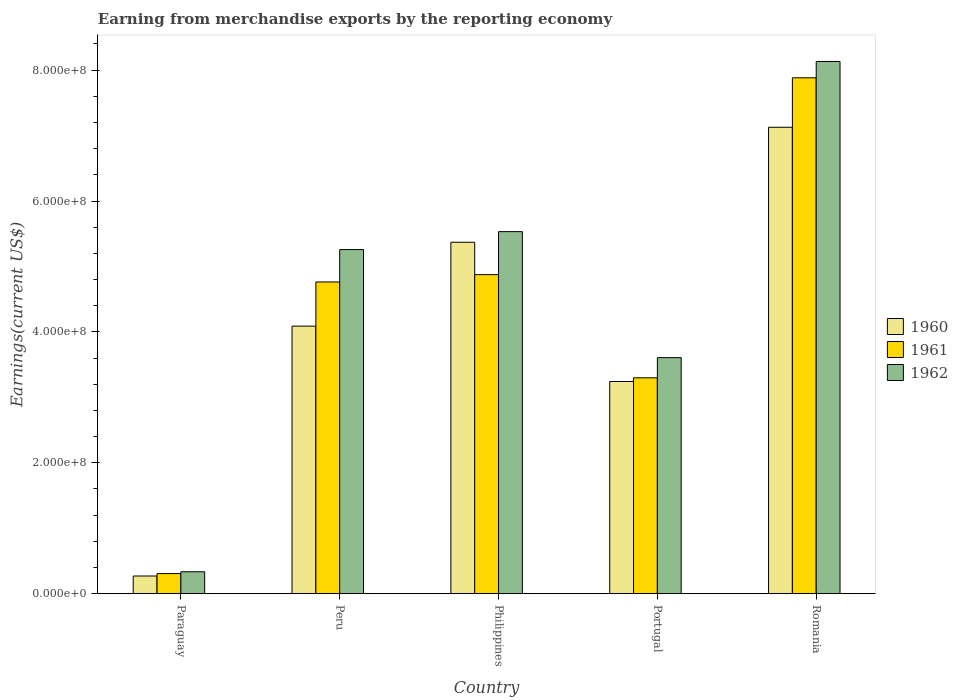How many groups of bars are there?
Ensure brevity in your answer.  5. Are the number of bars on each tick of the X-axis equal?
Provide a succinct answer. Yes. What is the label of the 1st group of bars from the left?
Give a very brief answer. Paraguay. In how many cases, is the number of bars for a given country not equal to the number of legend labels?
Make the answer very short. 0. What is the amount earned from merchandise exports in 1960 in Philippines?
Your response must be concise. 5.37e+08. Across all countries, what is the maximum amount earned from merchandise exports in 1962?
Your answer should be very brief. 8.13e+08. Across all countries, what is the minimum amount earned from merchandise exports in 1961?
Make the answer very short. 3.07e+07. In which country was the amount earned from merchandise exports in 1961 maximum?
Ensure brevity in your answer.  Romania. In which country was the amount earned from merchandise exports in 1961 minimum?
Provide a short and direct response. Paraguay. What is the total amount earned from merchandise exports in 1960 in the graph?
Provide a short and direct response. 2.01e+09. What is the difference between the amount earned from merchandise exports in 1961 in Philippines and that in Romania?
Your answer should be compact. -3.01e+08. What is the difference between the amount earned from merchandise exports in 1961 in Portugal and the amount earned from merchandise exports in 1962 in Peru?
Your answer should be compact. -1.96e+08. What is the average amount earned from merchandise exports in 1961 per country?
Your answer should be very brief. 4.23e+08. What is the difference between the amount earned from merchandise exports of/in 1961 and amount earned from merchandise exports of/in 1962 in Philippines?
Offer a very short reply. -6.57e+07. What is the ratio of the amount earned from merchandise exports in 1961 in Paraguay to that in Romania?
Ensure brevity in your answer.  0.04. Is the amount earned from merchandise exports in 1961 in Paraguay less than that in Philippines?
Provide a short and direct response. Yes. Is the difference between the amount earned from merchandise exports in 1961 in Paraguay and Portugal greater than the difference between the amount earned from merchandise exports in 1962 in Paraguay and Portugal?
Offer a terse response. Yes. What is the difference between the highest and the second highest amount earned from merchandise exports in 1962?
Your response must be concise. 2.87e+08. What is the difference between the highest and the lowest amount earned from merchandise exports in 1962?
Keep it short and to the point. 7.80e+08. Is the sum of the amount earned from merchandise exports in 1962 in Paraguay and Peru greater than the maximum amount earned from merchandise exports in 1960 across all countries?
Provide a short and direct response. No. What does the 2nd bar from the left in Paraguay represents?
Provide a short and direct response. 1961. What does the 2nd bar from the right in Paraguay represents?
Ensure brevity in your answer.  1961. How many bars are there?
Offer a terse response. 15. Are the values on the major ticks of Y-axis written in scientific E-notation?
Offer a terse response. Yes. Where does the legend appear in the graph?
Your answer should be compact. Center right. What is the title of the graph?
Your answer should be compact. Earning from merchandise exports by the reporting economy. What is the label or title of the X-axis?
Offer a terse response. Country. What is the label or title of the Y-axis?
Provide a succinct answer. Earnings(current US$). What is the Earnings(current US$) of 1960 in Paraguay?
Provide a short and direct response. 2.70e+07. What is the Earnings(current US$) in 1961 in Paraguay?
Your answer should be compact. 3.07e+07. What is the Earnings(current US$) of 1962 in Paraguay?
Offer a terse response. 3.35e+07. What is the Earnings(current US$) of 1960 in Peru?
Your answer should be compact. 4.09e+08. What is the Earnings(current US$) in 1961 in Peru?
Give a very brief answer. 4.76e+08. What is the Earnings(current US$) in 1962 in Peru?
Provide a short and direct response. 5.26e+08. What is the Earnings(current US$) in 1960 in Philippines?
Offer a very short reply. 5.37e+08. What is the Earnings(current US$) of 1961 in Philippines?
Provide a short and direct response. 4.88e+08. What is the Earnings(current US$) in 1962 in Philippines?
Your response must be concise. 5.53e+08. What is the Earnings(current US$) in 1960 in Portugal?
Offer a very short reply. 3.24e+08. What is the Earnings(current US$) in 1961 in Portugal?
Your answer should be very brief. 3.30e+08. What is the Earnings(current US$) in 1962 in Portugal?
Offer a terse response. 3.61e+08. What is the Earnings(current US$) of 1960 in Romania?
Offer a very short reply. 7.13e+08. What is the Earnings(current US$) of 1961 in Romania?
Your answer should be compact. 7.88e+08. What is the Earnings(current US$) in 1962 in Romania?
Offer a terse response. 8.13e+08. Across all countries, what is the maximum Earnings(current US$) of 1960?
Provide a succinct answer. 7.13e+08. Across all countries, what is the maximum Earnings(current US$) in 1961?
Make the answer very short. 7.88e+08. Across all countries, what is the maximum Earnings(current US$) of 1962?
Your answer should be compact. 8.13e+08. Across all countries, what is the minimum Earnings(current US$) in 1960?
Your response must be concise. 2.70e+07. Across all countries, what is the minimum Earnings(current US$) of 1961?
Your answer should be very brief. 3.07e+07. Across all countries, what is the minimum Earnings(current US$) of 1962?
Offer a terse response. 3.35e+07. What is the total Earnings(current US$) of 1960 in the graph?
Provide a succinct answer. 2.01e+09. What is the total Earnings(current US$) in 1961 in the graph?
Your response must be concise. 2.11e+09. What is the total Earnings(current US$) in 1962 in the graph?
Your answer should be very brief. 2.29e+09. What is the difference between the Earnings(current US$) in 1960 in Paraguay and that in Peru?
Provide a short and direct response. -3.82e+08. What is the difference between the Earnings(current US$) of 1961 in Paraguay and that in Peru?
Provide a short and direct response. -4.46e+08. What is the difference between the Earnings(current US$) in 1962 in Paraguay and that in Peru?
Provide a short and direct response. -4.92e+08. What is the difference between the Earnings(current US$) of 1960 in Paraguay and that in Philippines?
Ensure brevity in your answer.  -5.10e+08. What is the difference between the Earnings(current US$) in 1961 in Paraguay and that in Philippines?
Your answer should be very brief. -4.57e+08. What is the difference between the Earnings(current US$) of 1962 in Paraguay and that in Philippines?
Offer a terse response. -5.20e+08. What is the difference between the Earnings(current US$) of 1960 in Paraguay and that in Portugal?
Provide a succinct answer. -2.97e+08. What is the difference between the Earnings(current US$) in 1961 in Paraguay and that in Portugal?
Offer a very short reply. -2.99e+08. What is the difference between the Earnings(current US$) in 1962 in Paraguay and that in Portugal?
Your answer should be very brief. -3.27e+08. What is the difference between the Earnings(current US$) of 1960 in Paraguay and that in Romania?
Provide a short and direct response. -6.86e+08. What is the difference between the Earnings(current US$) of 1961 in Paraguay and that in Romania?
Your answer should be compact. -7.58e+08. What is the difference between the Earnings(current US$) of 1962 in Paraguay and that in Romania?
Ensure brevity in your answer.  -7.80e+08. What is the difference between the Earnings(current US$) in 1960 in Peru and that in Philippines?
Offer a terse response. -1.28e+08. What is the difference between the Earnings(current US$) in 1961 in Peru and that in Philippines?
Provide a succinct answer. -1.12e+07. What is the difference between the Earnings(current US$) of 1962 in Peru and that in Philippines?
Offer a very short reply. -2.74e+07. What is the difference between the Earnings(current US$) of 1960 in Peru and that in Portugal?
Your answer should be very brief. 8.46e+07. What is the difference between the Earnings(current US$) of 1961 in Peru and that in Portugal?
Offer a very short reply. 1.46e+08. What is the difference between the Earnings(current US$) in 1962 in Peru and that in Portugal?
Provide a succinct answer. 1.65e+08. What is the difference between the Earnings(current US$) of 1960 in Peru and that in Romania?
Your answer should be compact. -3.04e+08. What is the difference between the Earnings(current US$) in 1961 in Peru and that in Romania?
Your answer should be very brief. -3.12e+08. What is the difference between the Earnings(current US$) of 1962 in Peru and that in Romania?
Your response must be concise. -2.87e+08. What is the difference between the Earnings(current US$) of 1960 in Philippines and that in Portugal?
Provide a succinct answer. 2.13e+08. What is the difference between the Earnings(current US$) in 1961 in Philippines and that in Portugal?
Provide a short and direct response. 1.58e+08. What is the difference between the Earnings(current US$) of 1962 in Philippines and that in Portugal?
Ensure brevity in your answer.  1.93e+08. What is the difference between the Earnings(current US$) of 1960 in Philippines and that in Romania?
Provide a succinct answer. -1.76e+08. What is the difference between the Earnings(current US$) of 1961 in Philippines and that in Romania?
Keep it short and to the point. -3.01e+08. What is the difference between the Earnings(current US$) of 1962 in Philippines and that in Romania?
Your response must be concise. -2.60e+08. What is the difference between the Earnings(current US$) in 1960 in Portugal and that in Romania?
Give a very brief answer. -3.89e+08. What is the difference between the Earnings(current US$) of 1961 in Portugal and that in Romania?
Keep it short and to the point. -4.58e+08. What is the difference between the Earnings(current US$) in 1962 in Portugal and that in Romania?
Provide a short and direct response. -4.53e+08. What is the difference between the Earnings(current US$) in 1960 in Paraguay and the Earnings(current US$) in 1961 in Peru?
Give a very brief answer. -4.49e+08. What is the difference between the Earnings(current US$) in 1960 in Paraguay and the Earnings(current US$) in 1962 in Peru?
Make the answer very short. -4.99e+08. What is the difference between the Earnings(current US$) of 1961 in Paraguay and the Earnings(current US$) of 1962 in Peru?
Provide a short and direct response. -4.95e+08. What is the difference between the Earnings(current US$) in 1960 in Paraguay and the Earnings(current US$) in 1961 in Philippines?
Ensure brevity in your answer.  -4.61e+08. What is the difference between the Earnings(current US$) in 1960 in Paraguay and the Earnings(current US$) in 1962 in Philippines?
Make the answer very short. -5.26e+08. What is the difference between the Earnings(current US$) in 1961 in Paraguay and the Earnings(current US$) in 1962 in Philippines?
Offer a very short reply. -5.23e+08. What is the difference between the Earnings(current US$) of 1960 in Paraguay and the Earnings(current US$) of 1961 in Portugal?
Your response must be concise. -3.03e+08. What is the difference between the Earnings(current US$) of 1960 in Paraguay and the Earnings(current US$) of 1962 in Portugal?
Keep it short and to the point. -3.34e+08. What is the difference between the Earnings(current US$) in 1961 in Paraguay and the Earnings(current US$) in 1962 in Portugal?
Your response must be concise. -3.30e+08. What is the difference between the Earnings(current US$) in 1960 in Paraguay and the Earnings(current US$) in 1961 in Romania?
Your answer should be very brief. -7.61e+08. What is the difference between the Earnings(current US$) in 1960 in Paraguay and the Earnings(current US$) in 1962 in Romania?
Your answer should be compact. -7.86e+08. What is the difference between the Earnings(current US$) in 1961 in Paraguay and the Earnings(current US$) in 1962 in Romania?
Your answer should be very brief. -7.83e+08. What is the difference between the Earnings(current US$) in 1960 in Peru and the Earnings(current US$) in 1961 in Philippines?
Offer a terse response. -7.87e+07. What is the difference between the Earnings(current US$) of 1960 in Peru and the Earnings(current US$) of 1962 in Philippines?
Make the answer very short. -1.44e+08. What is the difference between the Earnings(current US$) of 1961 in Peru and the Earnings(current US$) of 1962 in Philippines?
Your response must be concise. -7.69e+07. What is the difference between the Earnings(current US$) of 1960 in Peru and the Earnings(current US$) of 1961 in Portugal?
Your response must be concise. 7.90e+07. What is the difference between the Earnings(current US$) of 1960 in Peru and the Earnings(current US$) of 1962 in Portugal?
Provide a succinct answer. 4.81e+07. What is the difference between the Earnings(current US$) in 1961 in Peru and the Earnings(current US$) in 1962 in Portugal?
Your answer should be compact. 1.16e+08. What is the difference between the Earnings(current US$) in 1960 in Peru and the Earnings(current US$) in 1961 in Romania?
Make the answer very short. -3.79e+08. What is the difference between the Earnings(current US$) in 1960 in Peru and the Earnings(current US$) in 1962 in Romania?
Give a very brief answer. -4.04e+08. What is the difference between the Earnings(current US$) in 1961 in Peru and the Earnings(current US$) in 1962 in Romania?
Your answer should be compact. -3.37e+08. What is the difference between the Earnings(current US$) in 1960 in Philippines and the Earnings(current US$) in 1961 in Portugal?
Offer a very short reply. 2.07e+08. What is the difference between the Earnings(current US$) of 1960 in Philippines and the Earnings(current US$) of 1962 in Portugal?
Provide a succinct answer. 1.76e+08. What is the difference between the Earnings(current US$) of 1961 in Philippines and the Earnings(current US$) of 1962 in Portugal?
Your answer should be very brief. 1.27e+08. What is the difference between the Earnings(current US$) of 1960 in Philippines and the Earnings(current US$) of 1961 in Romania?
Keep it short and to the point. -2.51e+08. What is the difference between the Earnings(current US$) of 1960 in Philippines and the Earnings(current US$) of 1962 in Romania?
Make the answer very short. -2.76e+08. What is the difference between the Earnings(current US$) of 1961 in Philippines and the Earnings(current US$) of 1962 in Romania?
Offer a very short reply. -3.26e+08. What is the difference between the Earnings(current US$) of 1960 in Portugal and the Earnings(current US$) of 1961 in Romania?
Your answer should be compact. -4.64e+08. What is the difference between the Earnings(current US$) of 1960 in Portugal and the Earnings(current US$) of 1962 in Romania?
Your answer should be very brief. -4.89e+08. What is the difference between the Earnings(current US$) in 1961 in Portugal and the Earnings(current US$) in 1962 in Romania?
Your answer should be very brief. -4.83e+08. What is the average Earnings(current US$) in 1960 per country?
Your answer should be very brief. 4.02e+08. What is the average Earnings(current US$) in 1961 per country?
Your answer should be compact. 4.23e+08. What is the average Earnings(current US$) of 1962 per country?
Your answer should be compact. 4.57e+08. What is the difference between the Earnings(current US$) in 1960 and Earnings(current US$) in 1961 in Paraguay?
Provide a succinct answer. -3.70e+06. What is the difference between the Earnings(current US$) of 1960 and Earnings(current US$) of 1962 in Paraguay?
Offer a very short reply. -6.49e+06. What is the difference between the Earnings(current US$) in 1961 and Earnings(current US$) in 1962 in Paraguay?
Keep it short and to the point. -2.79e+06. What is the difference between the Earnings(current US$) in 1960 and Earnings(current US$) in 1961 in Peru?
Ensure brevity in your answer.  -6.75e+07. What is the difference between the Earnings(current US$) in 1960 and Earnings(current US$) in 1962 in Peru?
Keep it short and to the point. -1.17e+08. What is the difference between the Earnings(current US$) in 1961 and Earnings(current US$) in 1962 in Peru?
Provide a succinct answer. -4.95e+07. What is the difference between the Earnings(current US$) in 1960 and Earnings(current US$) in 1961 in Philippines?
Offer a very short reply. 4.95e+07. What is the difference between the Earnings(current US$) in 1960 and Earnings(current US$) in 1962 in Philippines?
Ensure brevity in your answer.  -1.62e+07. What is the difference between the Earnings(current US$) in 1961 and Earnings(current US$) in 1962 in Philippines?
Provide a short and direct response. -6.57e+07. What is the difference between the Earnings(current US$) of 1960 and Earnings(current US$) of 1961 in Portugal?
Your response must be concise. -5.62e+06. What is the difference between the Earnings(current US$) in 1960 and Earnings(current US$) in 1962 in Portugal?
Provide a short and direct response. -3.65e+07. What is the difference between the Earnings(current US$) in 1961 and Earnings(current US$) in 1962 in Portugal?
Offer a very short reply. -3.09e+07. What is the difference between the Earnings(current US$) in 1960 and Earnings(current US$) in 1961 in Romania?
Provide a short and direct response. -7.56e+07. What is the difference between the Earnings(current US$) in 1960 and Earnings(current US$) in 1962 in Romania?
Ensure brevity in your answer.  -1.01e+08. What is the difference between the Earnings(current US$) in 1961 and Earnings(current US$) in 1962 in Romania?
Your answer should be very brief. -2.49e+07. What is the ratio of the Earnings(current US$) in 1960 in Paraguay to that in Peru?
Your answer should be very brief. 0.07. What is the ratio of the Earnings(current US$) in 1961 in Paraguay to that in Peru?
Ensure brevity in your answer.  0.06. What is the ratio of the Earnings(current US$) of 1962 in Paraguay to that in Peru?
Offer a terse response. 0.06. What is the ratio of the Earnings(current US$) of 1960 in Paraguay to that in Philippines?
Offer a very short reply. 0.05. What is the ratio of the Earnings(current US$) of 1961 in Paraguay to that in Philippines?
Your response must be concise. 0.06. What is the ratio of the Earnings(current US$) of 1962 in Paraguay to that in Philippines?
Your answer should be compact. 0.06. What is the ratio of the Earnings(current US$) in 1960 in Paraguay to that in Portugal?
Your response must be concise. 0.08. What is the ratio of the Earnings(current US$) of 1961 in Paraguay to that in Portugal?
Offer a very short reply. 0.09. What is the ratio of the Earnings(current US$) of 1962 in Paraguay to that in Portugal?
Your response must be concise. 0.09. What is the ratio of the Earnings(current US$) of 1960 in Paraguay to that in Romania?
Your answer should be very brief. 0.04. What is the ratio of the Earnings(current US$) in 1961 in Paraguay to that in Romania?
Your answer should be compact. 0.04. What is the ratio of the Earnings(current US$) in 1962 in Paraguay to that in Romania?
Give a very brief answer. 0.04. What is the ratio of the Earnings(current US$) in 1960 in Peru to that in Philippines?
Offer a terse response. 0.76. What is the ratio of the Earnings(current US$) in 1961 in Peru to that in Philippines?
Ensure brevity in your answer.  0.98. What is the ratio of the Earnings(current US$) in 1962 in Peru to that in Philippines?
Provide a succinct answer. 0.95. What is the ratio of the Earnings(current US$) of 1960 in Peru to that in Portugal?
Offer a terse response. 1.26. What is the ratio of the Earnings(current US$) in 1961 in Peru to that in Portugal?
Keep it short and to the point. 1.44. What is the ratio of the Earnings(current US$) of 1962 in Peru to that in Portugal?
Provide a short and direct response. 1.46. What is the ratio of the Earnings(current US$) in 1960 in Peru to that in Romania?
Give a very brief answer. 0.57. What is the ratio of the Earnings(current US$) in 1961 in Peru to that in Romania?
Your answer should be compact. 0.6. What is the ratio of the Earnings(current US$) in 1962 in Peru to that in Romania?
Offer a very short reply. 0.65. What is the ratio of the Earnings(current US$) in 1960 in Philippines to that in Portugal?
Your answer should be very brief. 1.66. What is the ratio of the Earnings(current US$) in 1961 in Philippines to that in Portugal?
Make the answer very short. 1.48. What is the ratio of the Earnings(current US$) of 1962 in Philippines to that in Portugal?
Offer a terse response. 1.53. What is the ratio of the Earnings(current US$) in 1960 in Philippines to that in Romania?
Your answer should be compact. 0.75. What is the ratio of the Earnings(current US$) in 1961 in Philippines to that in Romania?
Your answer should be compact. 0.62. What is the ratio of the Earnings(current US$) in 1962 in Philippines to that in Romania?
Ensure brevity in your answer.  0.68. What is the ratio of the Earnings(current US$) in 1960 in Portugal to that in Romania?
Make the answer very short. 0.45. What is the ratio of the Earnings(current US$) of 1961 in Portugal to that in Romania?
Give a very brief answer. 0.42. What is the ratio of the Earnings(current US$) in 1962 in Portugal to that in Romania?
Provide a succinct answer. 0.44. What is the difference between the highest and the second highest Earnings(current US$) in 1960?
Offer a terse response. 1.76e+08. What is the difference between the highest and the second highest Earnings(current US$) of 1961?
Your response must be concise. 3.01e+08. What is the difference between the highest and the second highest Earnings(current US$) in 1962?
Offer a very short reply. 2.60e+08. What is the difference between the highest and the lowest Earnings(current US$) in 1960?
Make the answer very short. 6.86e+08. What is the difference between the highest and the lowest Earnings(current US$) of 1961?
Provide a succinct answer. 7.58e+08. What is the difference between the highest and the lowest Earnings(current US$) in 1962?
Your answer should be very brief. 7.80e+08. 